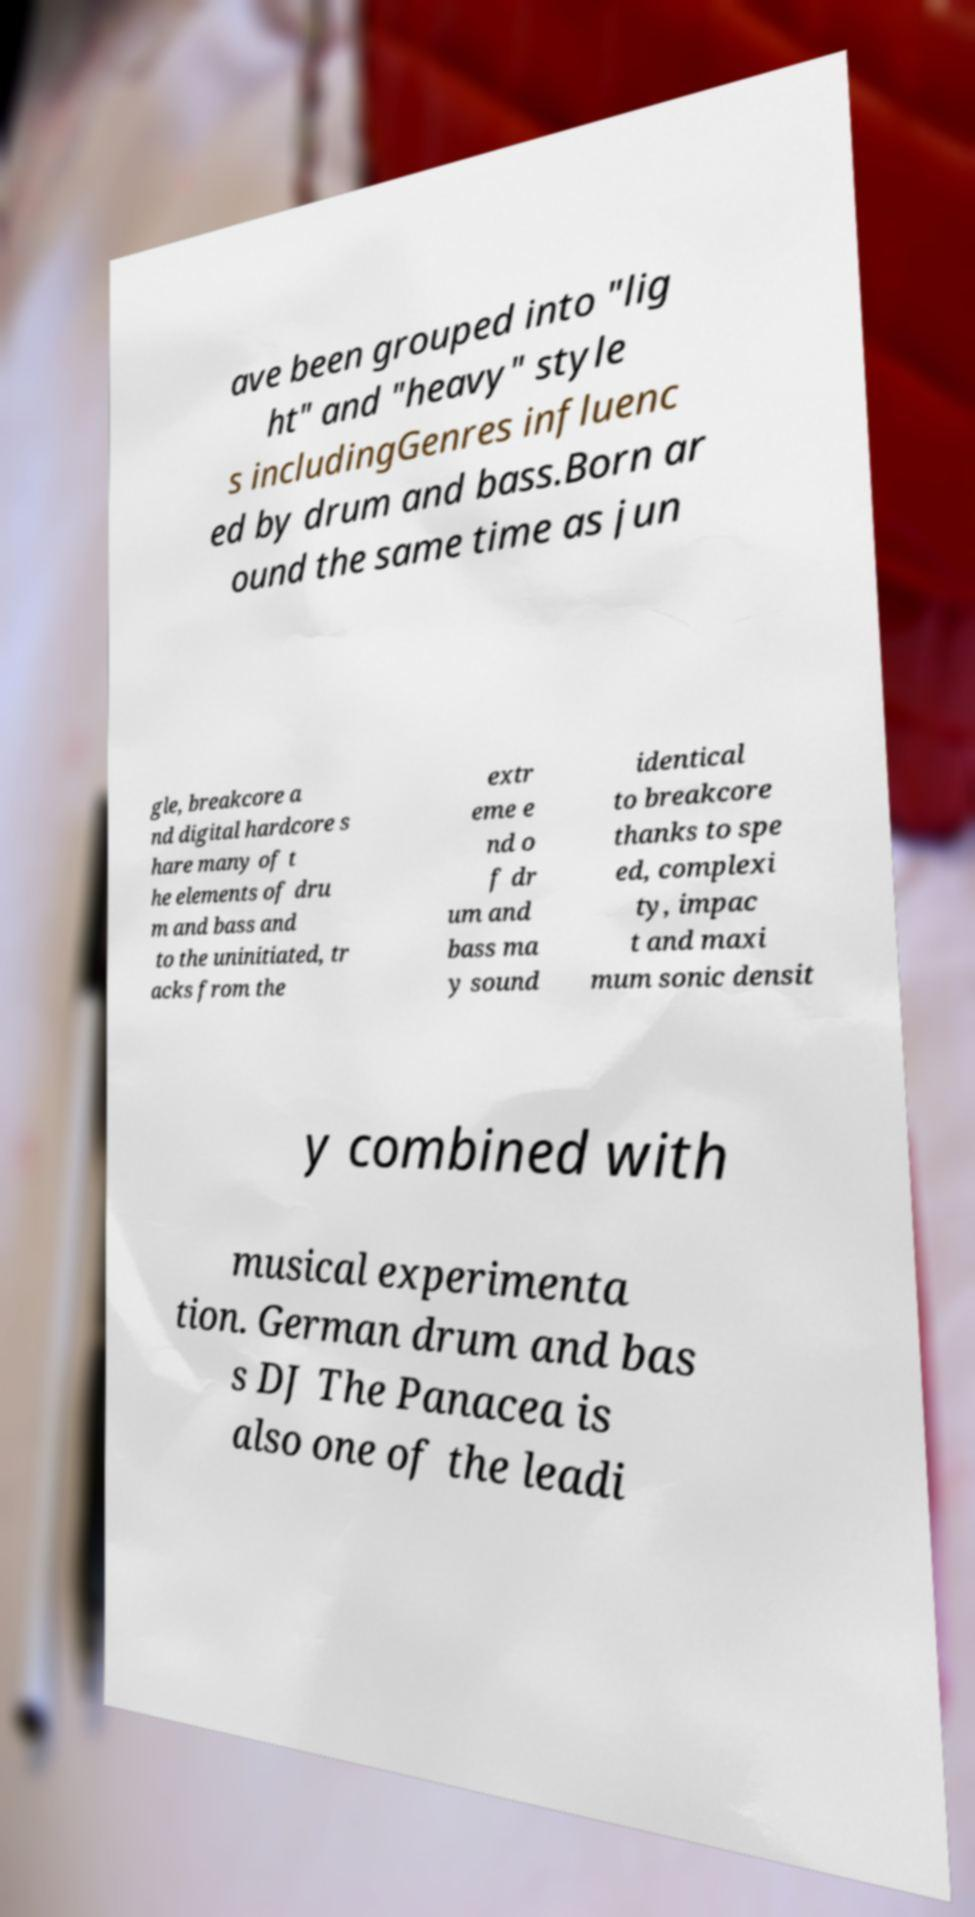Please read and relay the text visible in this image. What does it say? ave been grouped into "lig ht" and "heavy" style s includingGenres influenc ed by drum and bass.Born ar ound the same time as jun gle, breakcore a nd digital hardcore s hare many of t he elements of dru m and bass and to the uninitiated, tr acks from the extr eme e nd o f dr um and bass ma y sound identical to breakcore thanks to spe ed, complexi ty, impac t and maxi mum sonic densit y combined with musical experimenta tion. German drum and bas s DJ The Panacea is also one of the leadi 